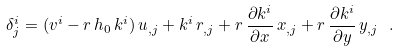<formula> <loc_0><loc_0><loc_500><loc_500>\delta ^ { i } _ { j } = ( v ^ { i } - r \, h _ { 0 } \, k ^ { i } ) \, u _ { , j } + k ^ { i } \, r _ { , j } + r \, \frac { \partial k ^ { i } } { \partial x } \, x _ { , j } + r \, \frac { \partial k ^ { i } } { \partial y } \, y _ { , j } \ .</formula> 